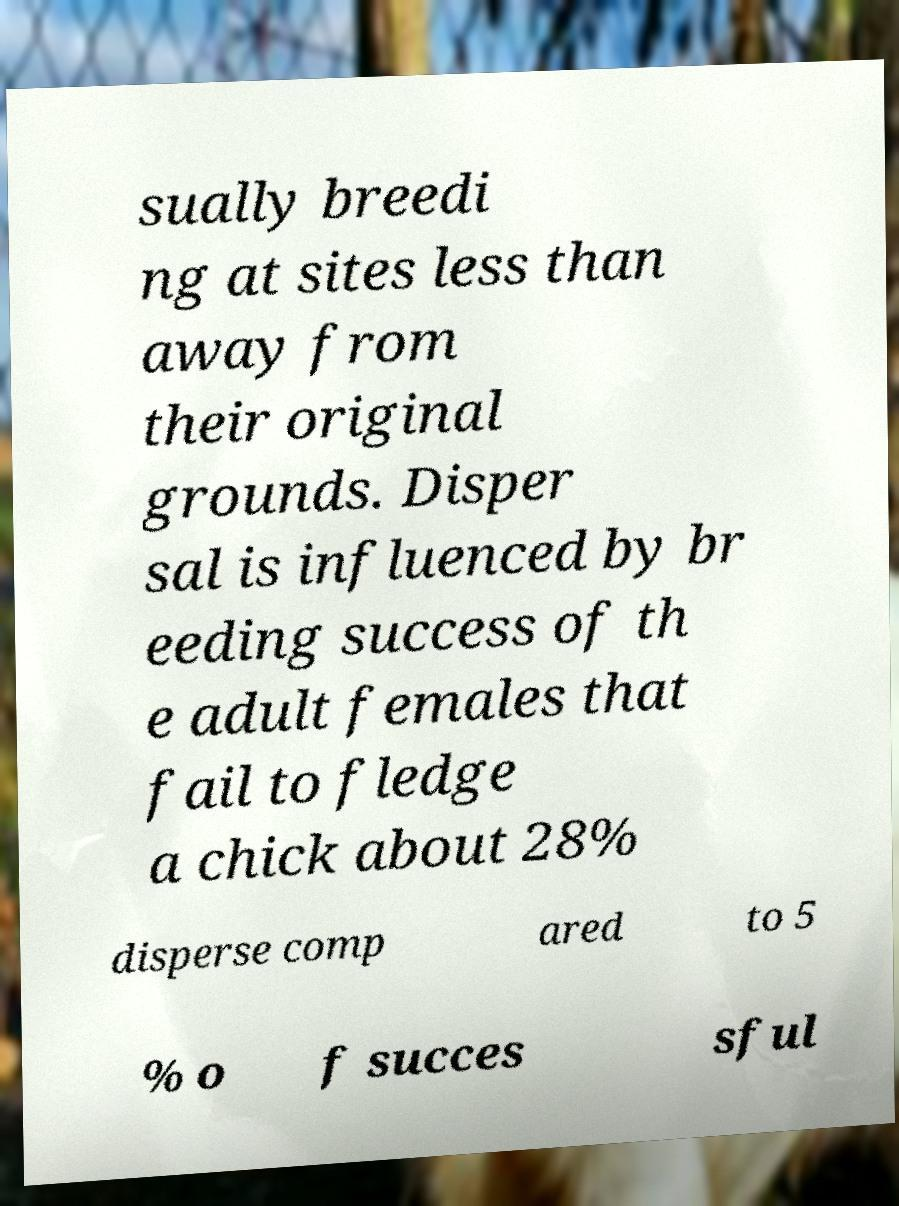Please identify and transcribe the text found in this image. sually breedi ng at sites less than away from their original grounds. Disper sal is influenced by br eeding success of th e adult females that fail to fledge a chick about 28% disperse comp ared to 5 % o f succes sful 